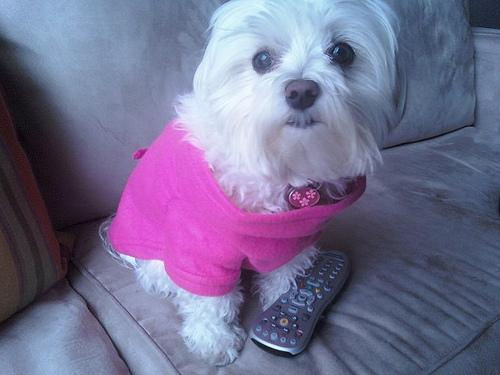What object is the item under the dog linked to? Please explain your reasoning. television. There is a remote. 